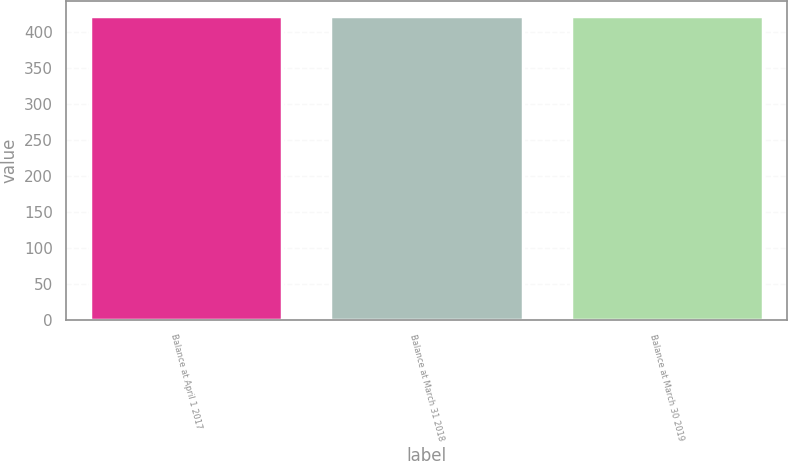Convert chart. <chart><loc_0><loc_0><loc_500><loc_500><bar_chart><fcel>Balance at April 1 2017<fcel>Balance at March 31 2018<fcel>Balance at March 30 2019<nl><fcel>421.8<fcel>421.9<fcel>422<nl></chart> 